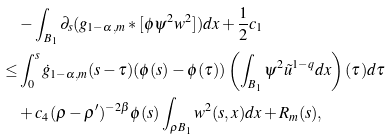Convert formula to latex. <formula><loc_0><loc_0><loc_500><loc_500>& - \int _ { B _ { 1 } } \partial _ { s } ( g _ { 1 - \alpha , m } * [ \phi \psi ^ { 2 } w ^ { 2 } ] ) d x + \frac { 1 } { 2 } c _ { 1 } \\ \leq & \int _ { 0 } ^ { s } \dot { g } _ { 1 - \alpha , m } ( s - \tau ) ( \phi ( s ) - \phi ( \tau ) ) \left ( \int _ { B _ { 1 } } \psi ^ { 2 } \tilde { u } ^ { 1 - q } d x \right ) ( \tau ) d \tau \\ & + c _ { 4 } ( \rho - \rho ^ { \prime } ) ^ { - 2 \beta } \phi ( s ) \int _ { \rho B _ { 1 } } w ^ { 2 } ( s , x ) d x + R _ { m } ( s ) ,</formula> 